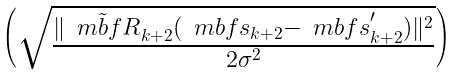Convert formula to latex. <formula><loc_0><loc_0><loc_500><loc_500>\begin{pmatrix} \sqrt { \frac { \| \tilde { \ m b f { R } } _ { k + 2 } ( \ m b f { s } _ { k + 2 } - \ m b f { s } _ { k + 2 } ^ { ^ { \prime } } ) \| ^ { 2 } } { 2 \sigma ^ { 2 } } } \end{pmatrix}</formula> 